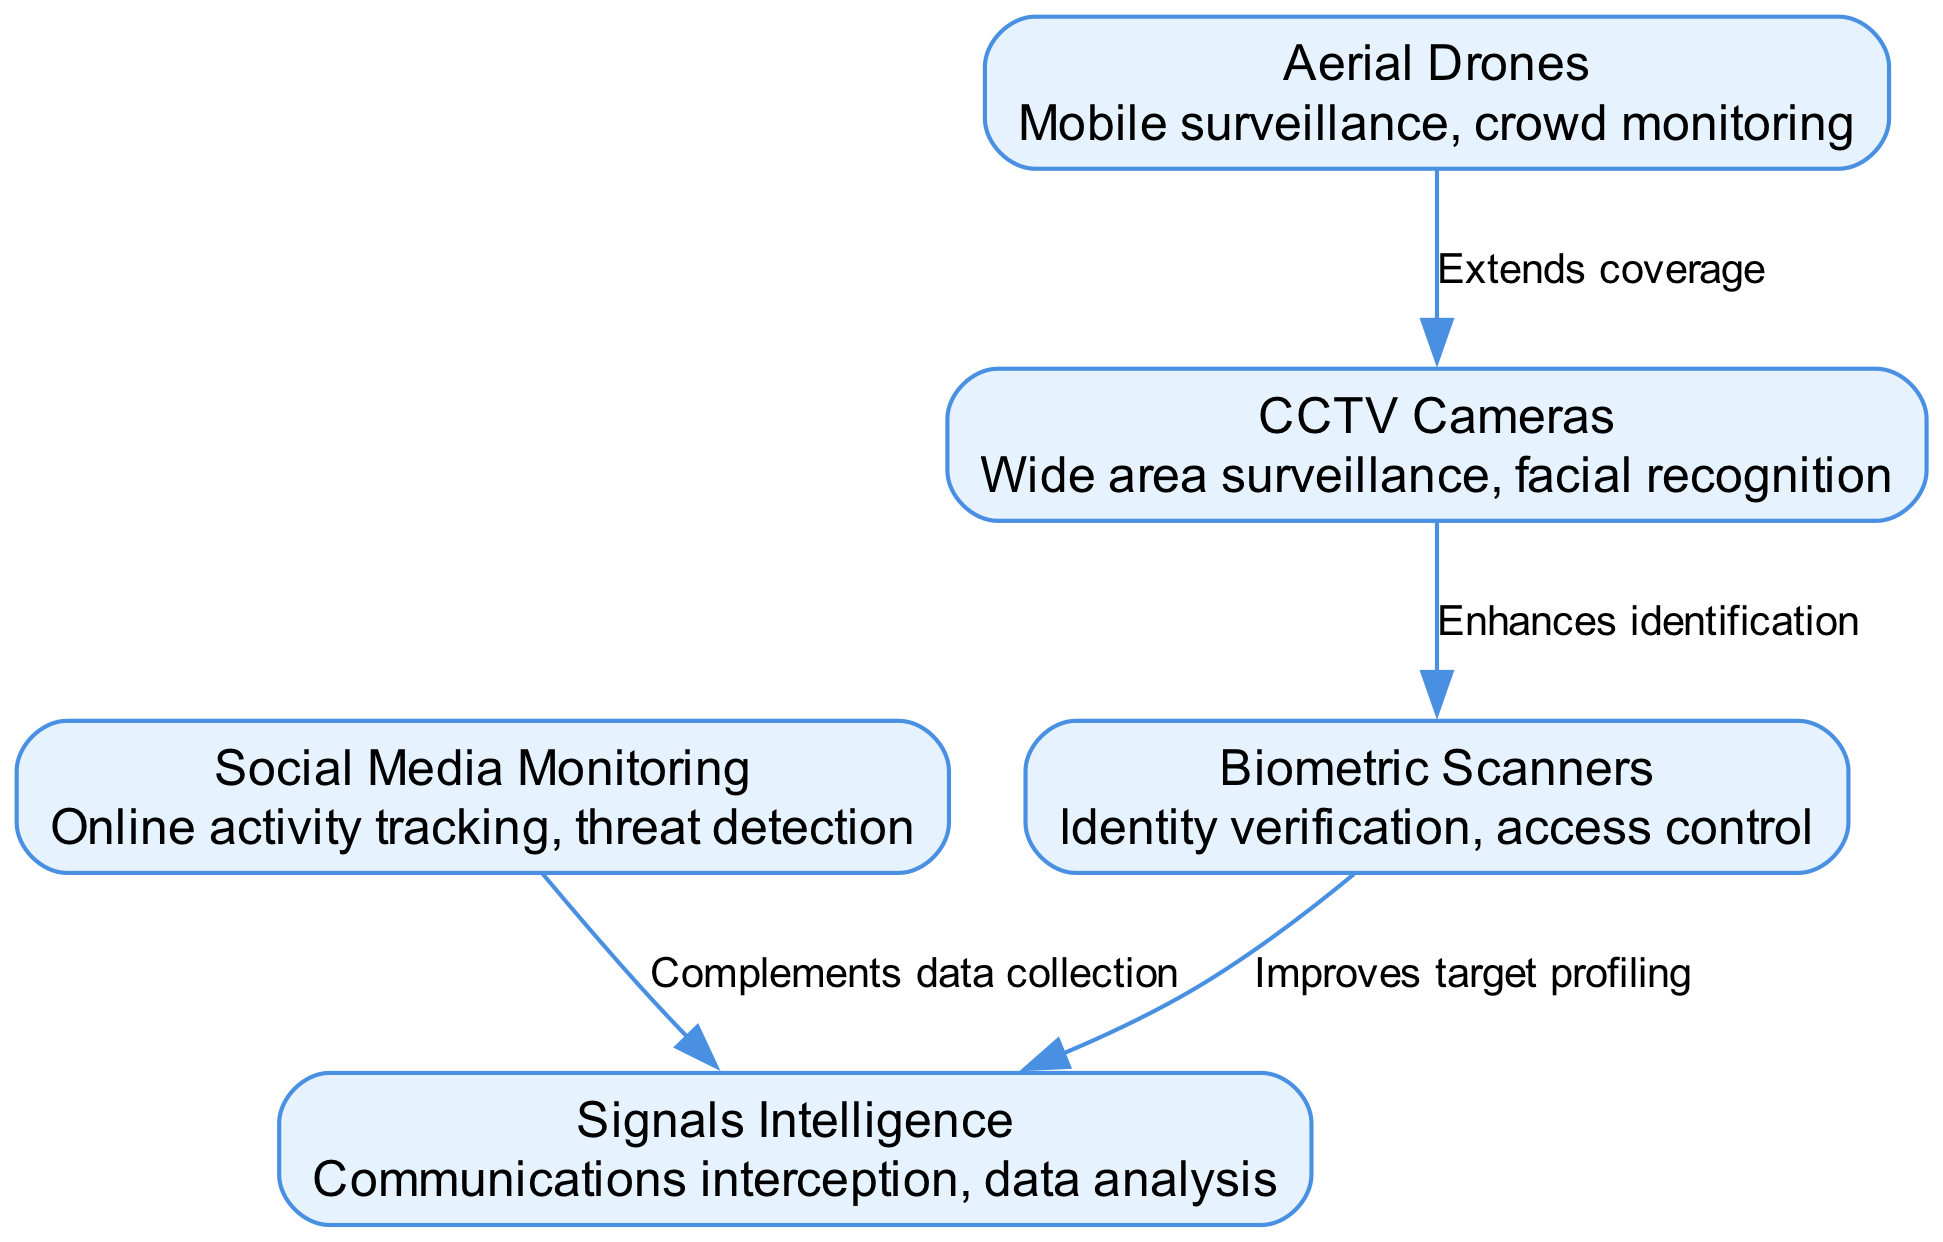What technologies are compared in the diagram? The diagram lists five technologies: CCTV Cameras, Aerial Drones, Biometric Scanners, Social Media Monitoring, and Signals Intelligence.
Answer: CCTV Cameras, Aerial Drones, Biometric Scanners, Social Media Monitoring, Signals Intelligence How many nodes are present in the diagram? By counting the items in the nodes list, there are five distinct surveillance technologies represented, which are the primary nodes in the diagram.
Answer: 5 What does the edge from CCTV to Biometrics represent? The edge indicates that CCTV cameras enhance the identification process when used in conjunction with biometric scanners, suggesting a relationship that improves security measures.
Answer: Enhances identification Which technology extends coverage according to the diagram? Aerial Drones are indicated as the technology that extends the coverage of surveillance systems, allowing for broader monitoring capabilities compared to stationary technologies.
Answer: Aerial Drones What is the role of Social Media Monitoring in relation to Signals Intelligence? Social Media Monitoring complements Signals Intelligence by providing additional data collection, thus enhancing the overall intelligence-gathering efforts.
Answer: Complements data collection Which two technologies improve target profiling together? The relationship between Biometric Scanners and Signals Intelligence suggests that both technologies work together to enhance the profiling of targets, leading to better security management.
Answer: Biometric Scanners and Signals Intelligence How does the diagram illustrate the relationship between Drones and CCTV? The arrow pointing from Drones to CCTV signifies that Drones can be utilized to enhance the coverage area of CCTV cameras, suggesting a strategic integration of these technologies.
Answer: Extends coverage What key capability is associated with Biometric Scanners? The primary capability associated with Biometric Scanners is identity verification, indicating their role in confirming individuals' identities through physical traits.
Answer: Identity verification 